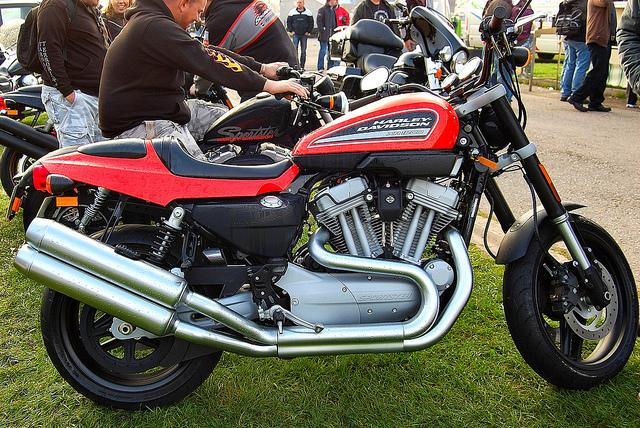What was the first name of Mr. Harley?

Choices:
A) sean
B) john
C) william
D) mark william 